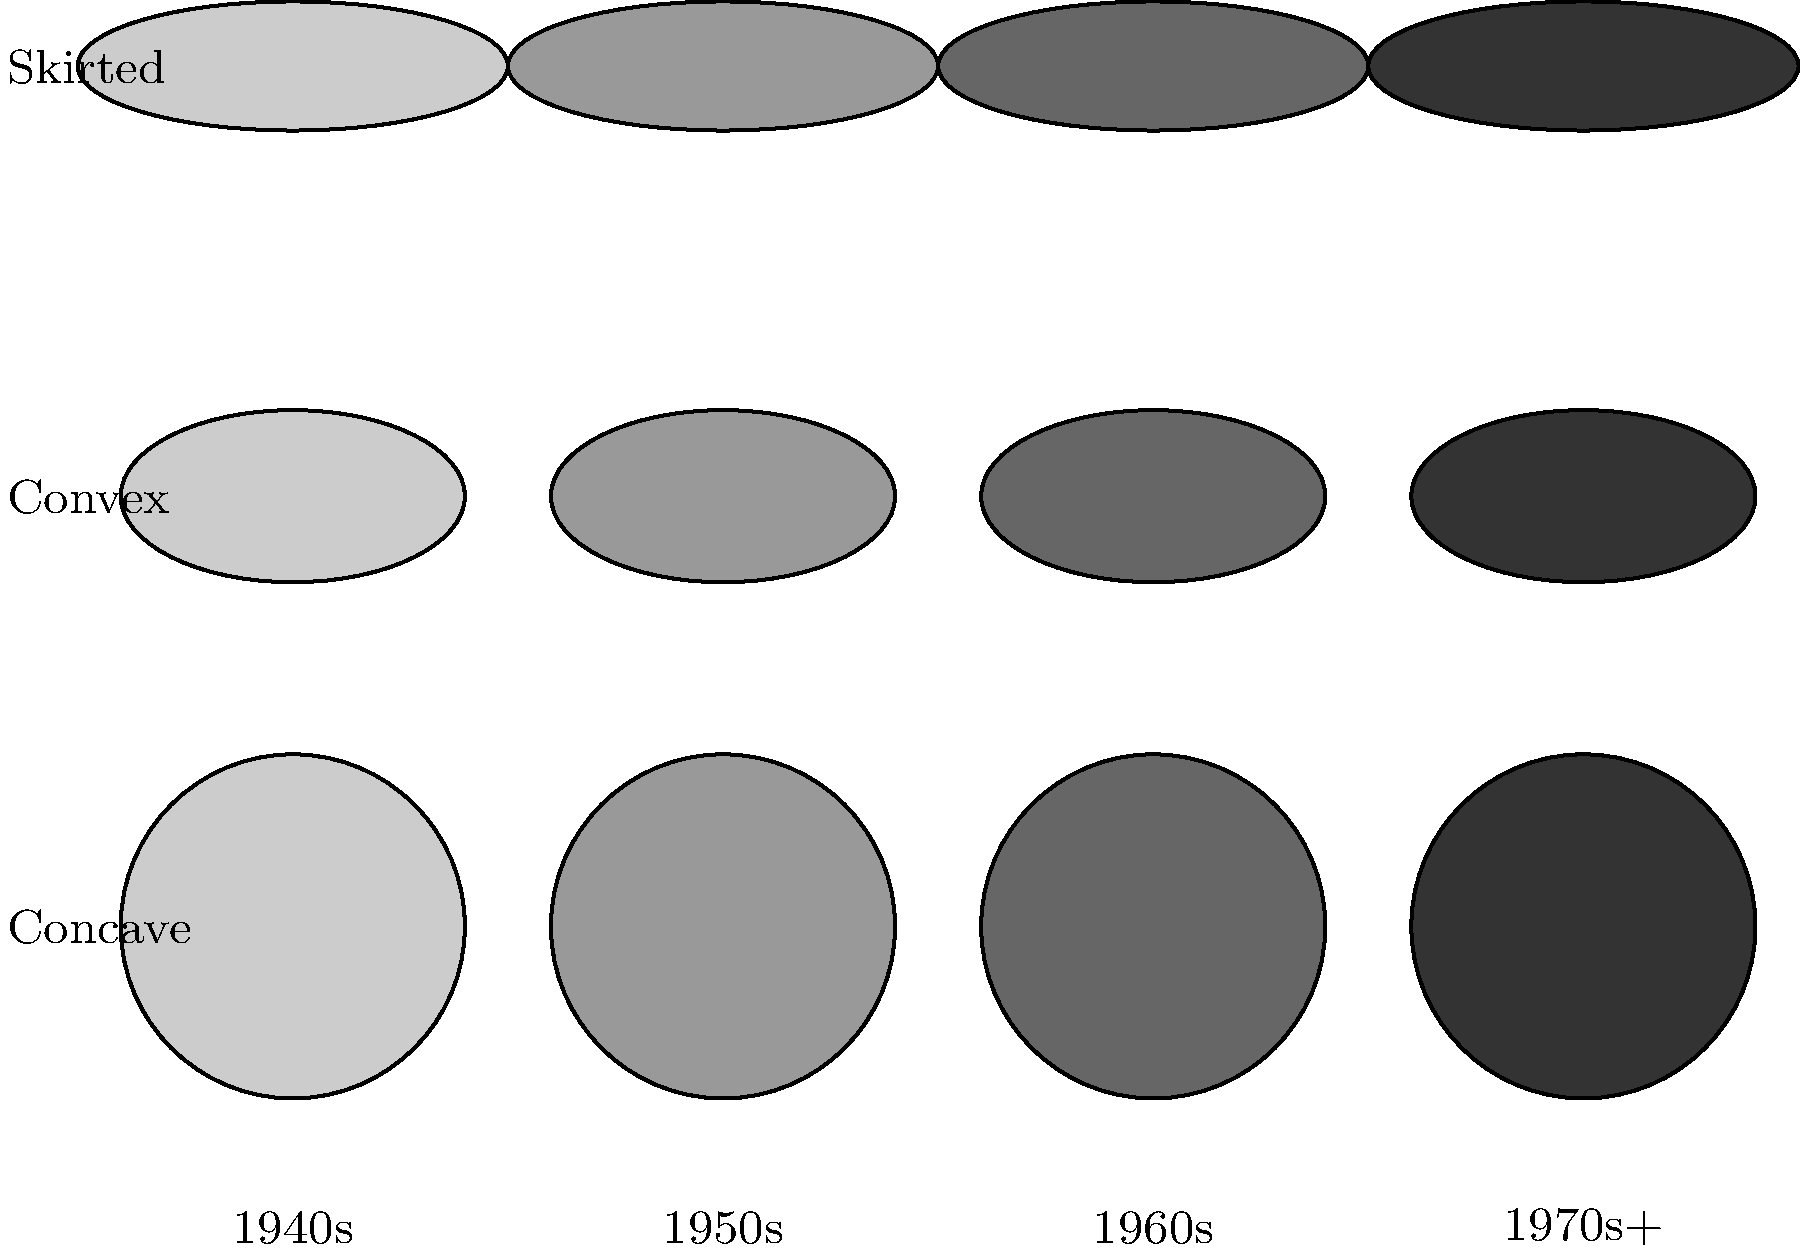Based on the diagram showing the evolution of steel pan design, which decade marked the transition from primarily concave to convex pan surfaces? To answer this question, let's analyze the diagram step-by-step:

1. The diagram shows the evolution of steel pan design across four time periods: 1940s, 1950s, 1960s, and 1970s+.

2. There are three rows representing different pan surface designs:
   - Bottom row: Concave surfaces
   - Middle row: Convex surfaces
   - Top row: Skirted designs

3. Examining the bottom row (concave surfaces):
   - 1940s: Fully shaded, indicating prevalent use
   - 1950s: Partially shaded, suggesting decreased but still significant use
   - 1960s and 1970s+: Lightly shaded, indicating minimal use

4. Looking at the middle row (convex surfaces):
   - 1940s: Lightly shaded, suggesting minimal or experimental use
   - 1950s: Partially shaded, indicating increased adoption
   - 1960s and 1970s+: Fully shaded, showing prevalent use

5. The transition from primarily concave to convex surfaces is most evident in the 1950s column, where both designs are partially shaded.

Therefore, the 1950s marked the transition from primarily concave to convex pan surfaces.
Answer: 1950s 